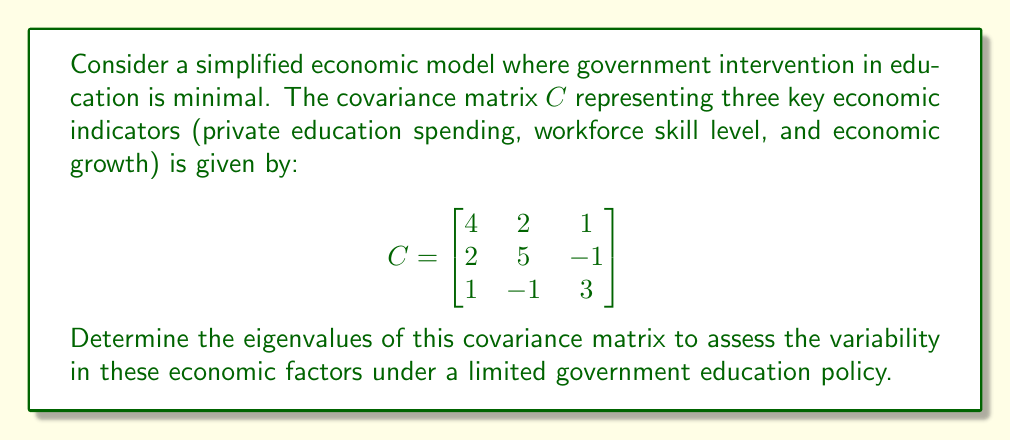Teach me how to tackle this problem. To find the eigenvalues of the covariance matrix $C$, we need to solve the characteristic equation:

$$\det(C - \lambda I) = 0$$

where $I$ is the 3x3 identity matrix and $\lambda$ represents the eigenvalues.

Step 1: Set up the characteristic equation:
$$\det\begin{pmatrix}
4-\lambda & 2 & 1 \\
2 & 5-\lambda & -1 \\
1 & -1 & 3-\lambda
\end{pmatrix} = 0$$

Step 2: Expand the determinant:
$$(4-\lambda)[(5-\lambda)(3-\lambda) + 1] - 2[2(3-\lambda) - 1] + 1[2(-1) - (5-\lambda)] = 0$$

Step 3: Simplify:
$$(4-\lambda)(15-8\lambda+\lambda^2+1) - 2(6-2\lambda-1) + (-2-5+\lambda) = 0$$
$$(4-\lambda)(16-8\lambda+\lambda^2) - 2(5-2\lambda) + (\lambda-7) = 0$$
$$64-32\lambda+4\lambda^2-16\lambda+8\lambda^2-\lambda^3-10+4\lambda+\lambda-7 = 0$$

Step 4: Collect terms:
$$-\lambda^3+12\lambda^2-44\lambda+47 = 0$$

Step 5: Factor the cubic equation:
$$-(\lambda-1)(\lambda-3)(\lambda-8) = 0$$

Step 6: Solve for $\lambda$:
The eigenvalues are the roots of this equation: $\lambda = 1, 3, 8$
Answer: $\lambda_1 = 1, \lambda_2 = 3, \lambda_3 = 8$ 